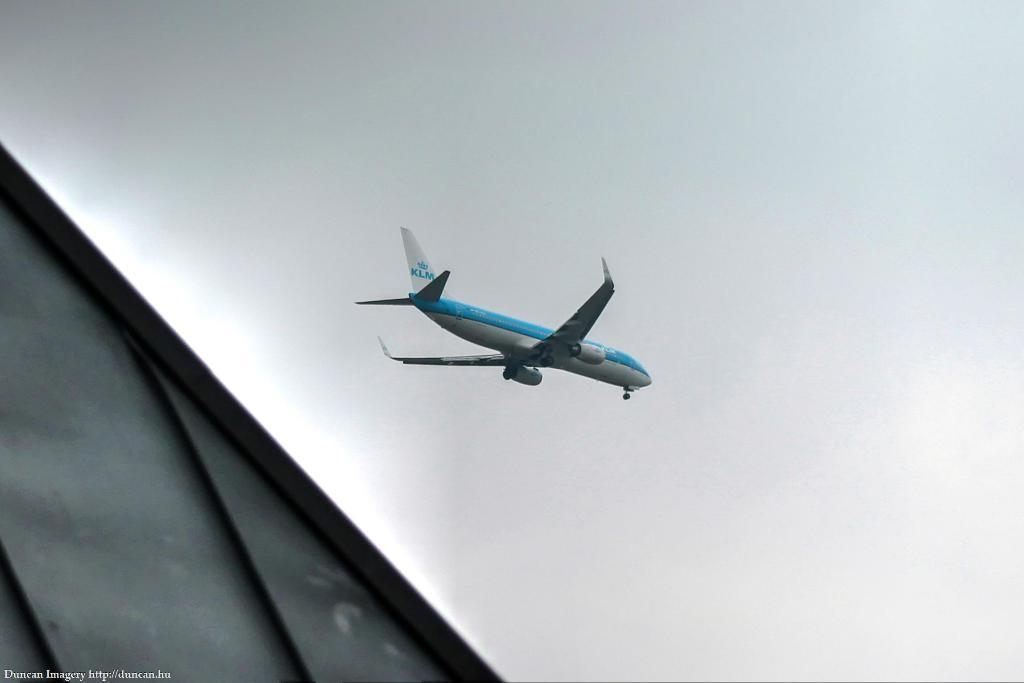What is the main subject of the image? The main subject of the image is an airplane. What is the airplane doing in the image? The airplane is flying in the sky. How would you describe the sky in the image? The sky is clear in the image. Can you see any scissors being used to cut the clouds in the image? There are no scissors or clouds present in the image, and therefore no such activity can be observed. 